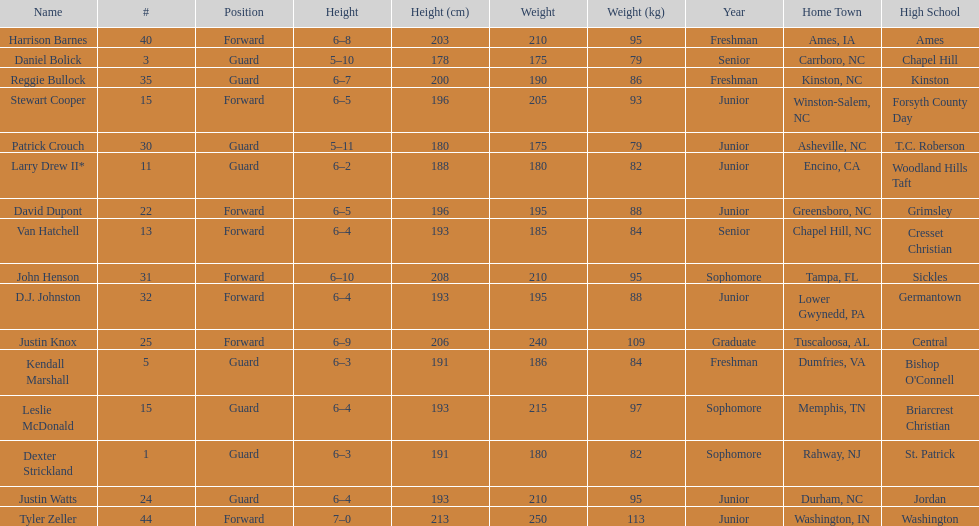What was the number of freshmen on the team? 3. 